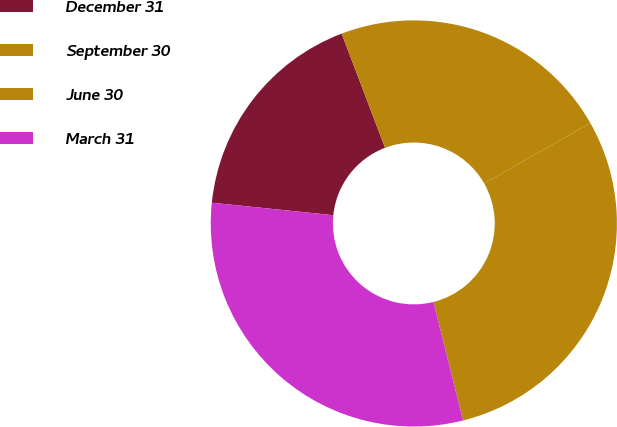Convert chart. <chart><loc_0><loc_0><loc_500><loc_500><pie_chart><fcel>December 31<fcel>September 30<fcel>June 30<fcel>March 31<nl><fcel>17.59%<fcel>22.55%<fcel>29.33%<fcel>30.53%<nl></chart> 